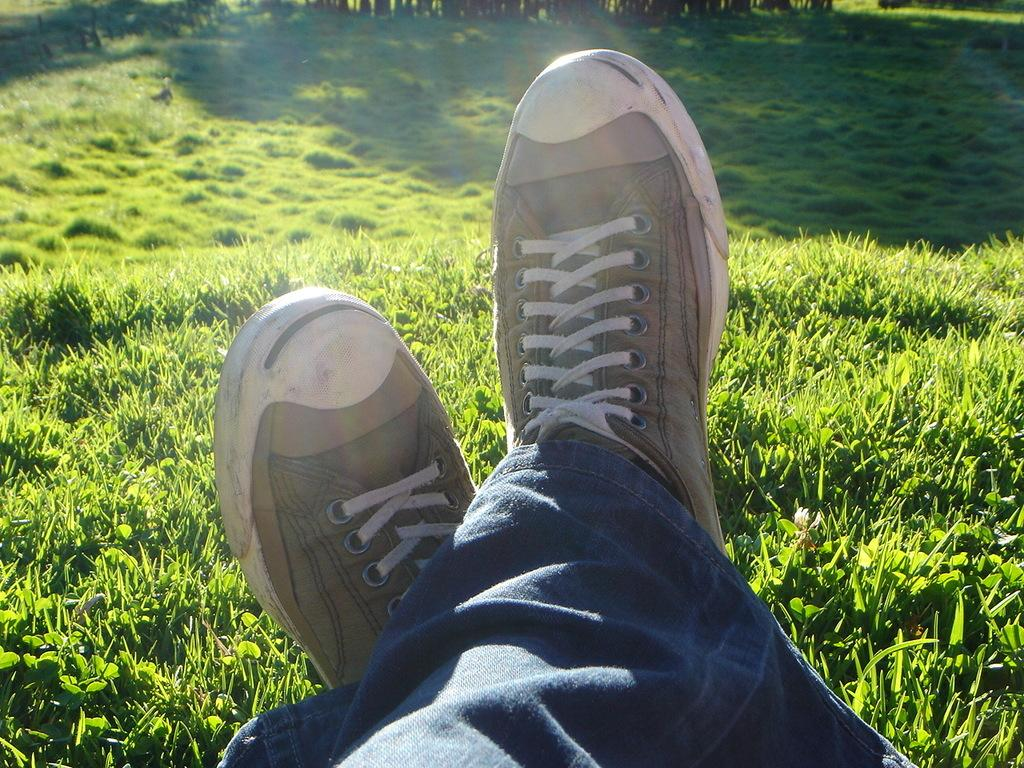What type of vegetation is present in the image? There is grass in the image. Can you describe the lower body of the person in the image? The person has legs visible in the image. What type of clothing is the person wearing on their legs? The person is wearing blue jeans. What type of footwear is the person wearing? The person is wearing shoes. What type of industry is depicted in the image? There is no industry depicted in the image; it features grass and a person wearing blue jeans and shoes. What rhythm is the person in the image following? There is no rhythm or movement being depicted in the image; it is a still image of a person standing on grass. 